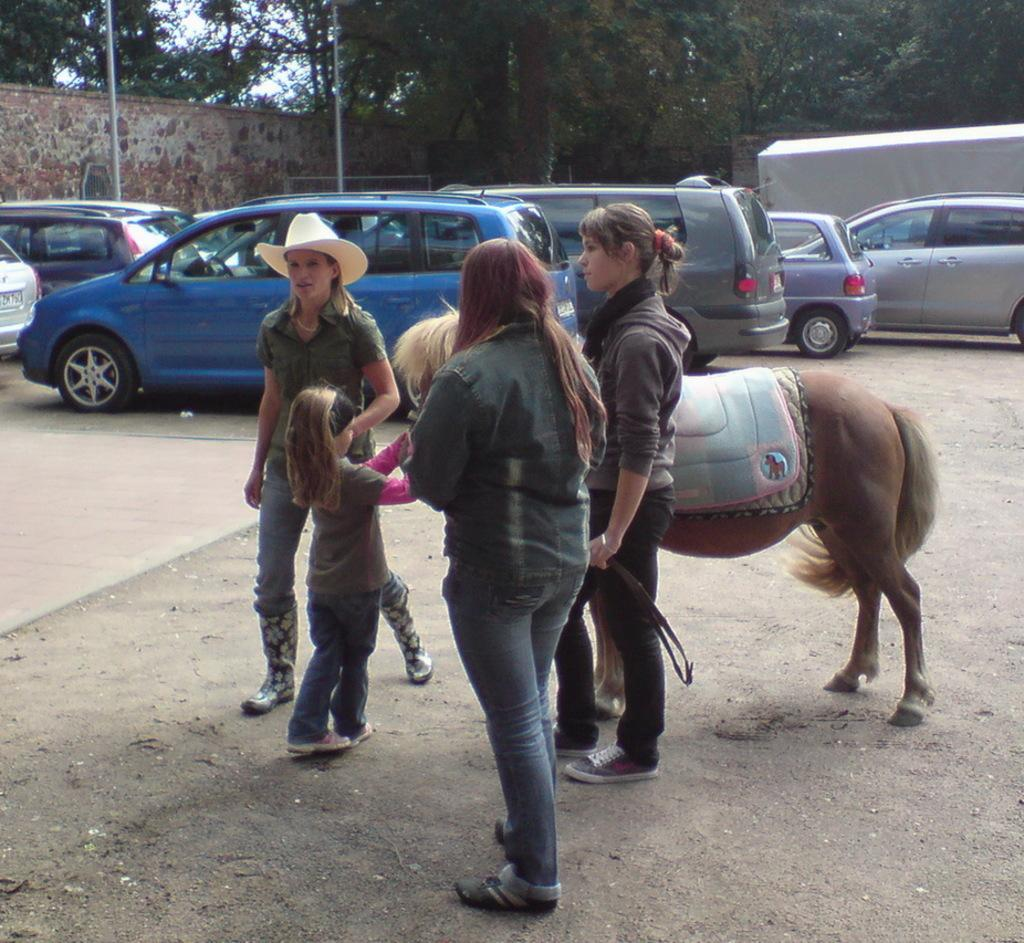How many people are in the image? There are four persons in the image. What are the persons doing in the image? The persons are standing beside a horse. What can be seen in the distance in the image? There are vehicles and trees in the distance. Can you describe the attire of one of the persons? One person is wearing a hat. What type of stick is being used to measure the heat in the image? There is no stick or measurement of heat present in the image. 